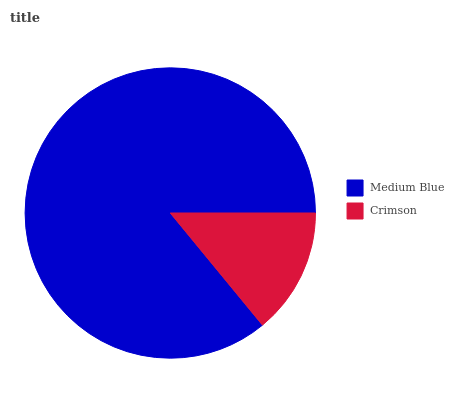Is Crimson the minimum?
Answer yes or no. Yes. Is Medium Blue the maximum?
Answer yes or no. Yes. Is Crimson the maximum?
Answer yes or no. No. Is Medium Blue greater than Crimson?
Answer yes or no. Yes. Is Crimson less than Medium Blue?
Answer yes or no. Yes. Is Crimson greater than Medium Blue?
Answer yes or no. No. Is Medium Blue less than Crimson?
Answer yes or no. No. Is Medium Blue the high median?
Answer yes or no. Yes. Is Crimson the low median?
Answer yes or no. Yes. Is Crimson the high median?
Answer yes or no. No. Is Medium Blue the low median?
Answer yes or no. No. 